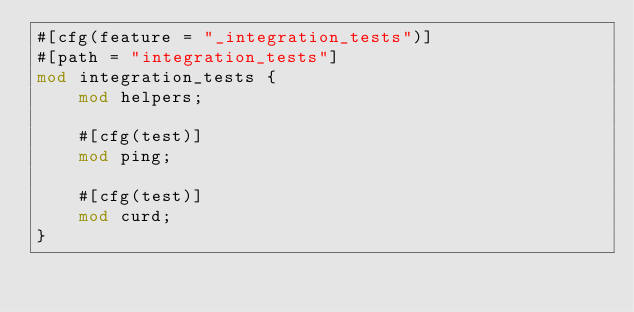Convert code to text. <code><loc_0><loc_0><loc_500><loc_500><_Rust_>#[cfg(feature = "_integration_tests")]
#[path = "integration_tests"]
mod integration_tests {
    mod helpers;

    #[cfg(test)]
    mod ping;

    #[cfg(test)]
    mod curd;
}
</code> 